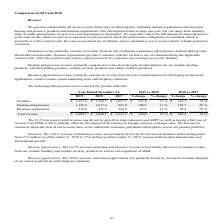From Godaddy's financial document, Which three types of revenues are listed in the table? The document contains multiple relevant values: Domains, Hosting and presence, Business applications. From the document: "Business applications 510.0 422.2 326.8 87.8 21 % 95.4 29 % 1.6 $ 1,220.3 $ 1,057.2 $ 131.3 11 % $ 163.1 15 % Hosting and presence 1,126.5 1,017.6 847..." Also, What is the domain revenue for each financial year in chronological order? The document contains multiple relevant values: $ 1,057.2, $ 1,220.3, $ 1,351.6. From the document: "Domains $ 1,351.6 $ 1,220.3 $ 1,057.2 $ 131.3 11 % $ 163.1 15 % Hosting and presence 1,126.5 1,017.6 847.9 108.9 11 % 169.7 20 % Domains $ 1,351.6 $ 1..." Also, What is the hosting and presence revenue for each financial year in chronological order? The document contains multiple relevant values: 847.9, 1,017.6, 1,126.5. From the document: "$ 163.1 15 % Hosting and presence 1,126.5 1,017.6 847.9 108.9 11 % 169.7 20 % .3 11 % $ 163.1 15 % Hosting and presence 1,126.5 1,017.6 847.9 108.9 11..." Also, How many types of revenues are there? Counting the relevant items in the document: Domains ,  Hosting and presence ,  Business applications, I find 3 instances. The key data points involved are: Business applications, Domains, Hosting and presence. Also, can you calculate: What is the average domain revenue for 2018 and 2019? To answer this question, I need to perform calculations using the financial data. The calculation is: (1,351.6+1,220.3)/2, which equals 1285.95. This is based on the information: "Domains $ 1,351.6 $ 1,220.3 $ 1,057.2 $ 131.3 11 % $ 163.1 15 % Hosting and presence 1,126.5 1,017.6 847.9 108.9 11 % 169.7 20 Domains $ 1,351.6 $ 1,220.3 $ 1,057.2 $ 131.3 11 % $ 163.1 15 % Hosting a..." The key data points involved are: 1,220.3, 1,351.6. Also, can you calculate: What is the average hosting and presence revenue for 2018 and 2019? To answer this question, I need to perform calculations using the financial data. The calculation is: (1,126.5+1,017.6)/2, which equals 1072.05. This is based on the information: ".3 11 % $ 163.1 15 % Hosting and presence 1,126.5 1,017.6 847.9 108.9 11 % 169.7 20 % .2 $ 131.3 11 % $ 163.1 15 % Hosting and presence 1,126.5 1,017.6 847.9 108.9 11 % 169.7 20 %..." The key data points involved are: 1,017.6, 1,126.5. 